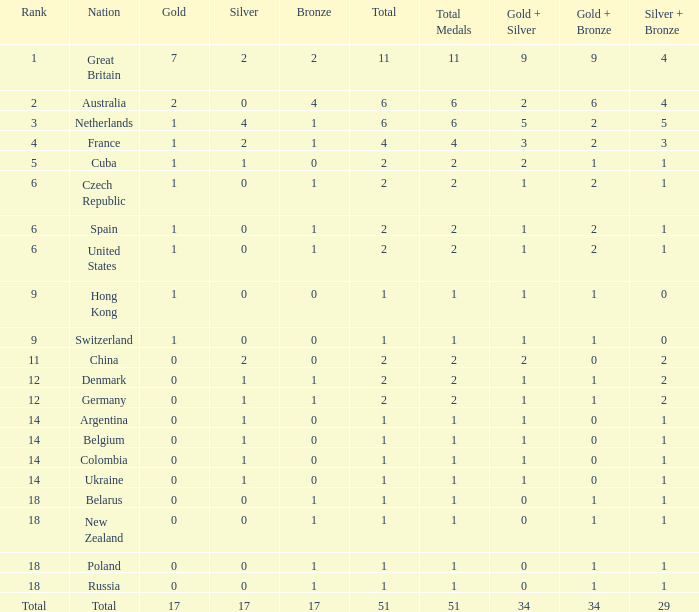Tell me the lowest gold for rank of 6 and total less than 2 None. 